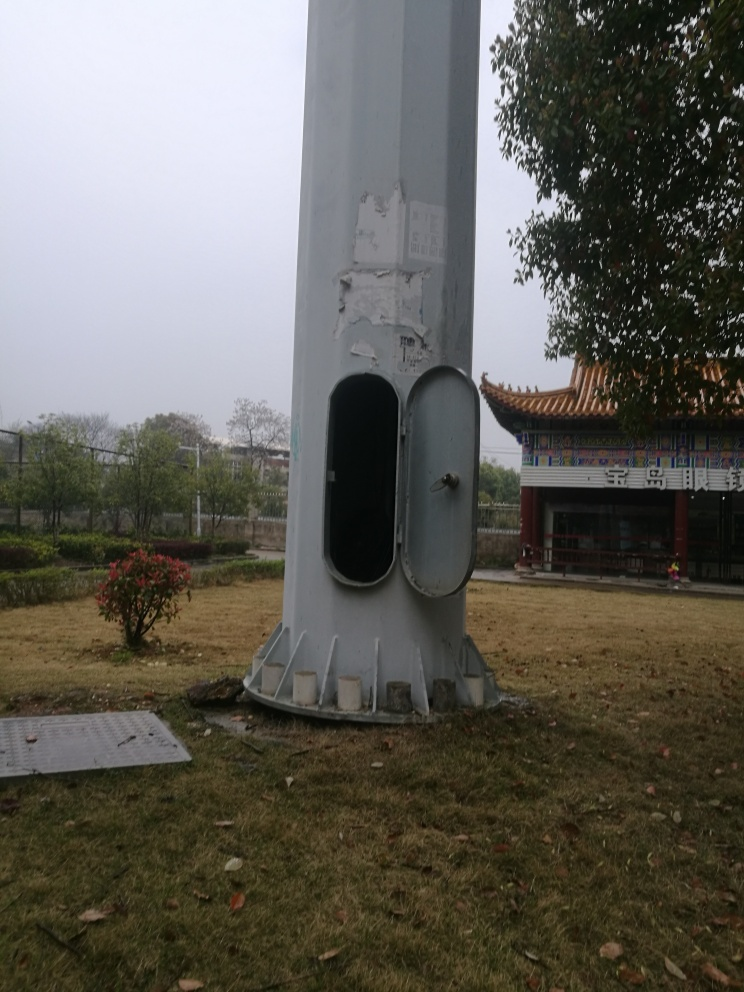Can you describe the setting of this image? The image appears to show an outdoor setting with a large, cylindrical column, possibly part of an infrastructure or utility. There's a metal door inset in the column and a traditional East Asian style building can be seen in the background. The ground is covered with grass and fallen leaves, suggesting this might be a public or semi-public space. 